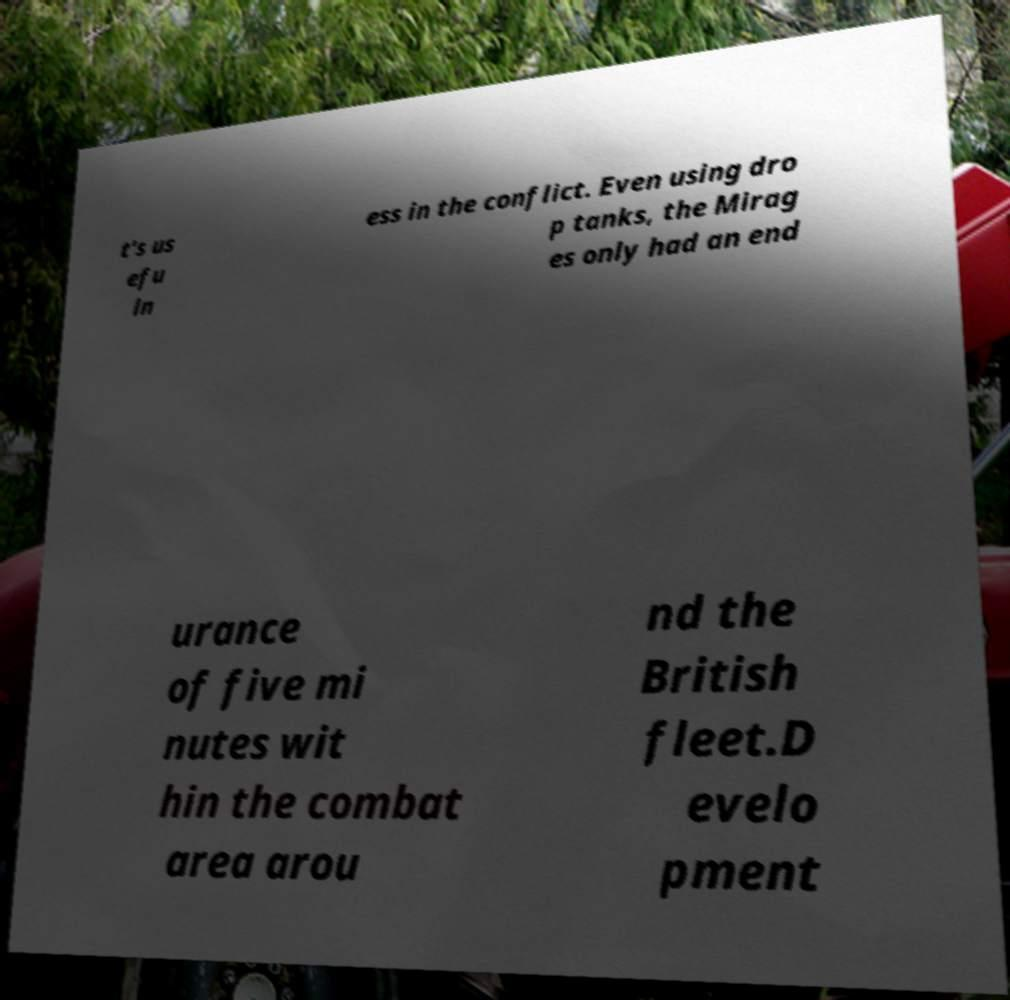What messages or text are displayed in this image? I need them in a readable, typed format. t's us efu ln ess in the conflict. Even using dro p tanks, the Mirag es only had an end urance of five mi nutes wit hin the combat area arou nd the British fleet.D evelo pment 